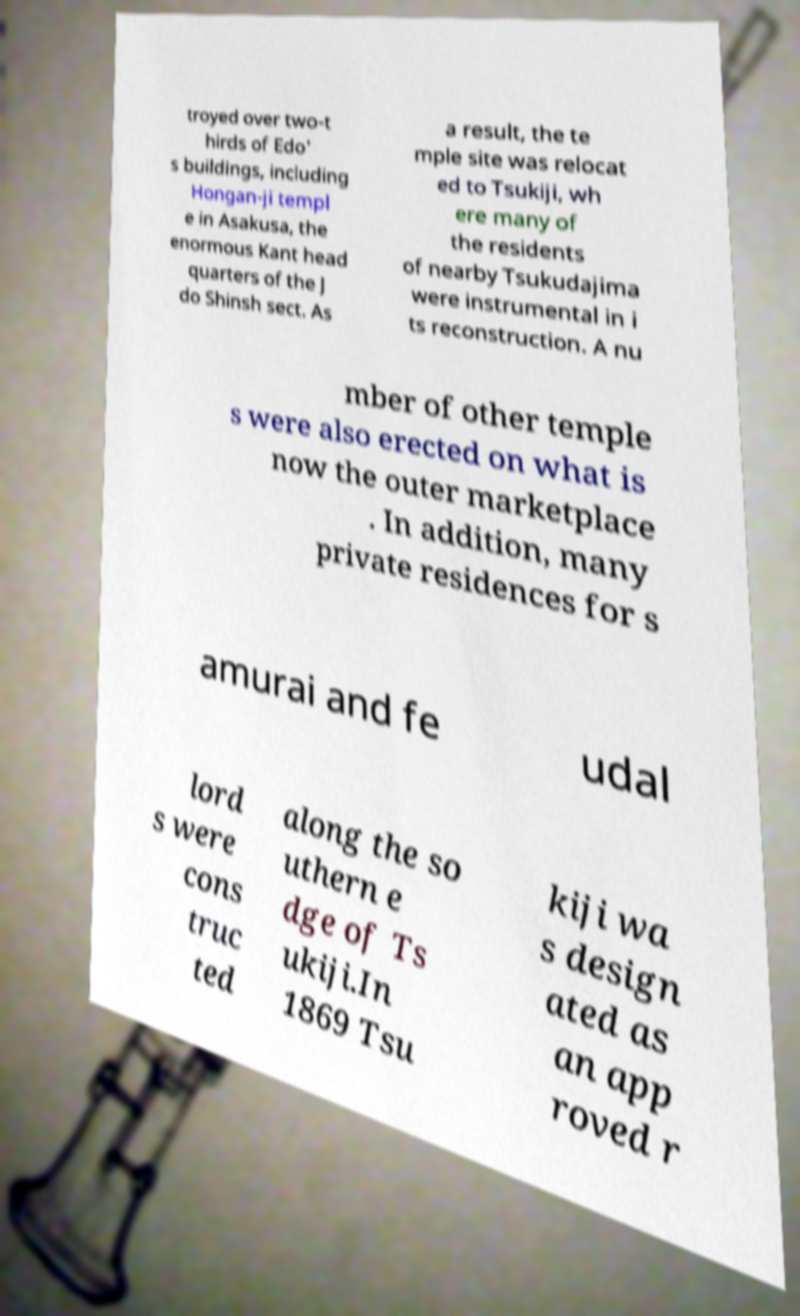There's text embedded in this image that I need extracted. Can you transcribe it verbatim? troyed over two-t hirds of Edo' s buildings, including Hongan-ji templ e in Asakusa, the enormous Kant head quarters of the J do Shinsh sect. As a result, the te mple site was relocat ed to Tsukiji, wh ere many of the residents of nearby Tsukudajima were instrumental in i ts reconstruction. A nu mber of other temple s were also erected on what is now the outer marketplace . In addition, many private residences for s amurai and fe udal lord s were cons truc ted along the so uthern e dge of Ts ukiji.In 1869 Tsu kiji wa s design ated as an app roved r 